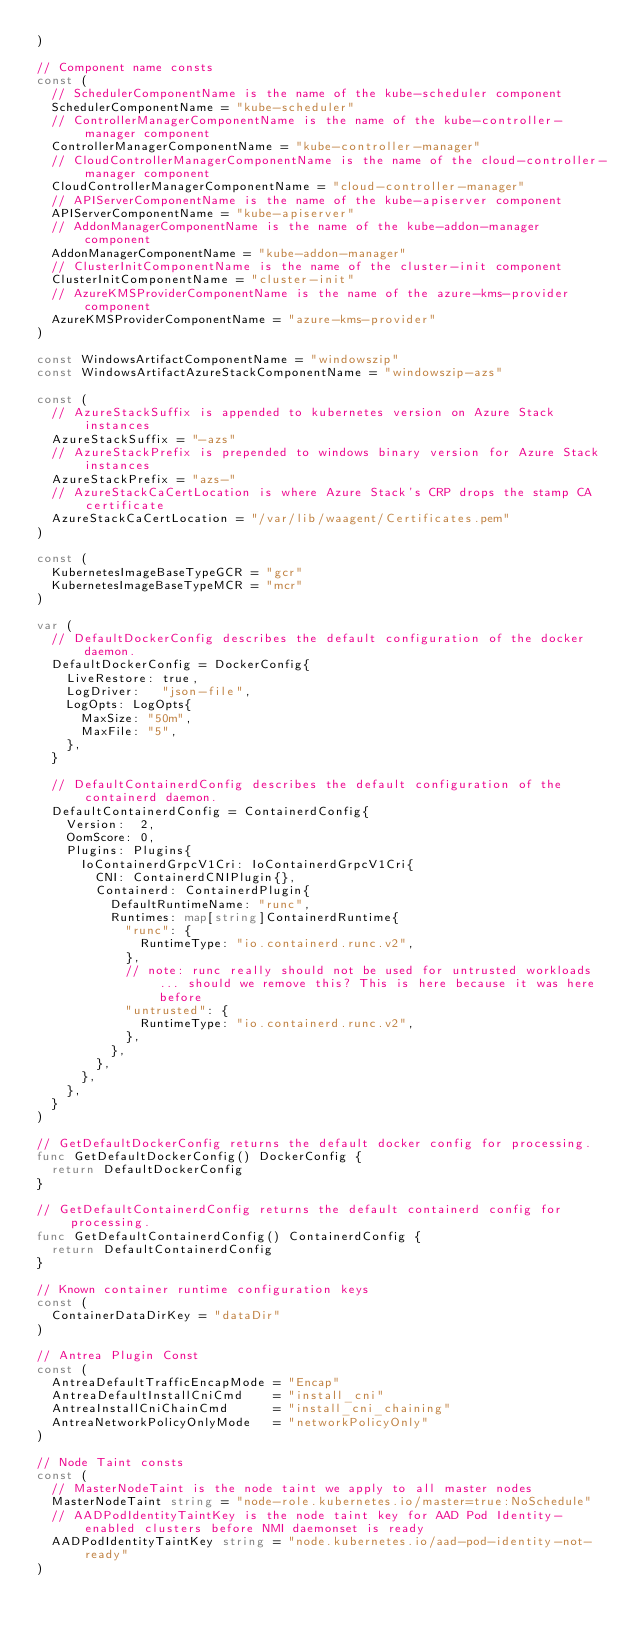Convert code to text. <code><loc_0><loc_0><loc_500><loc_500><_Go_>)

// Component name consts
const (
	// SchedulerComponentName is the name of the kube-scheduler component
	SchedulerComponentName = "kube-scheduler"
	// ControllerManagerComponentName is the name of the kube-controller-manager component
	ControllerManagerComponentName = "kube-controller-manager"
	// CloudControllerManagerComponentName is the name of the cloud-controller-manager component
	CloudControllerManagerComponentName = "cloud-controller-manager"
	// APIServerComponentName is the name of the kube-apiserver component
	APIServerComponentName = "kube-apiserver"
	// AddonManagerComponentName is the name of the kube-addon-manager component
	AddonManagerComponentName = "kube-addon-manager"
	// ClusterInitComponentName is the name of the cluster-init component
	ClusterInitComponentName = "cluster-init"
	// AzureKMSProviderComponentName is the name of the azure-kms-provider component
	AzureKMSProviderComponentName = "azure-kms-provider"
)

const WindowsArtifactComponentName = "windowszip"
const WindowsArtifactAzureStackComponentName = "windowszip-azs"

const (
	// AzureStackSuffix is appended to kubernetes version on Azure Stack instances
	AzureStackSuffix = "-azs"
	// AzureStackPrefix is prepended to windows binary version for Azure Stack instances
	AzureStackPrefix = "azs-"
	// AzureStackCaCertLocation is where Azure Stack's CRP drops the stamp CA certificate
	AzureStackCaCertLocation = "/var/lib/waagent/Certificates.pem"
)

const (
	KubernetesImageBaseTypeGCR = "gcr"
	KubernetesImageBaseTypeMCR = "mcr"
)

var (
	// DefaultDockerConfig describes the default configuration of the docker daemon.
	DefaultDockerConfig = DockerConfig{
		LiveRestore: true,
		LogDriver:   "json-file",
		LogOpts: LogOpts{
			MaxSize: "50m",
			MaxFile: "5",
		},
	}

	// DefaultContainerdConfig describes the default configuration of the containerd daemon.
	DefaultContainerdConfig = ContainerdConfig{
		Version:  2,
		OomScore: 0,
		Plugins: Plugins{
			IoContainerdGrpcV1Cri: IoContainerdGrpcV1Cri{
				CNI: ContainerdCNIPlugin{},
				Containerd: ContainerdPlugin{
					DefaultRuntimeName: "runc",
					Runtimes: map[string]ContainerdRuntime{
						"runc": {
							RuntimeType: "io.containerd.runc.v2",
						},
						// note: runc really should not be used for untrusted workloads... should we remove this? This is here because it was here before
						"untrusted": {
							RuntimeType: "io.containerd.runc.v2",
						},
					},
				},
			},
		},
	}
)

// GetDefaultDockerConfig returns the default docker config for processing.
func GetDefaultDockerConfig() DockerConfig {
	return DefaultDockerConfig
}

// GetDefaultContainerdConfig returns the default containerd config for processing.
func GetDefaultContainerdConfig() ContainerdConfig {
	return DefaultContainerdConfig
}

// Known container runtime configuration keys
const (
	ContainerDataDirKey = "dataDir"
)

// Antrea Plugin Const
const (
	AntreaDefaultTrafficEncapMode = "Encap"
	AntreaDefaultInstallCniCmd    = "install_cni"
	AntreaInstallCniChainCmd      = "install_cni_chaining"
	AntreaNetworkPolicyOnlyMode   = "networkPolicyOnly"
)

// Node Taint consts
const (
	// MasterNodeTaint is the node taint we apply to all master nodes
	MasterNodeTaint string = "node-role.kubernetes.io/master=true:NoSchedule"
	// AADPodIdentityTaintKey is the node taint key for AAD Pod Identity-enabled clusters before NMI daemonset is ready
	AADPodIdentityTaintKey string = "node.kubernetes.io/aad-pod-identity-not-ready"
)
</code> 